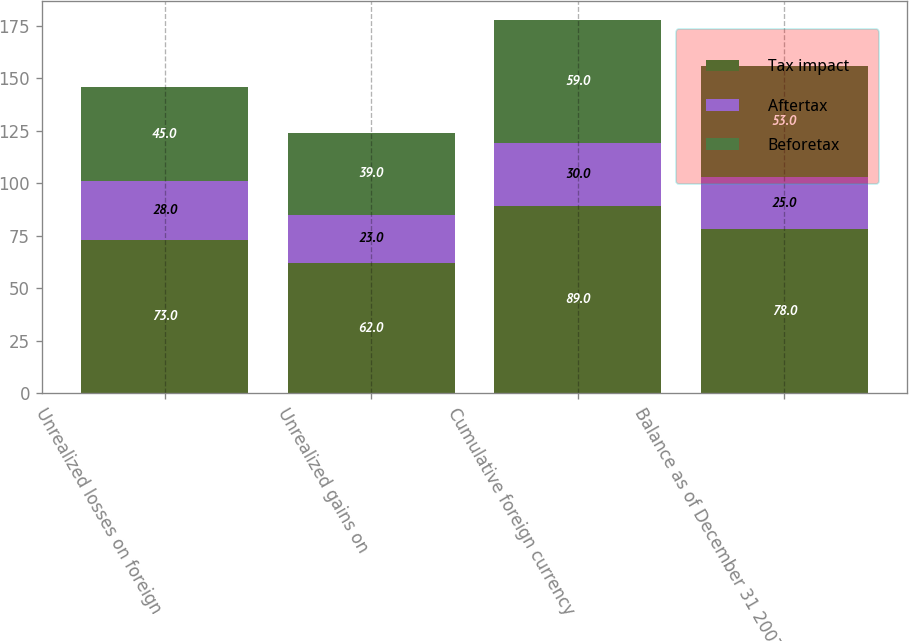Convert chart to OTSL. <chart><loc_0><loc_0><loc_500><loc_500><stacked_bar_chart><ecel><fcel>Unrealized losses on foreign<fcel>Unrealized gains on<fcel>Cumulative foreign currency<fcel>Balance as of December 31 2007<nl><fcel>Tax impact<fcel>73<fcel>62<fcel>89<fcel>78<nl><fcel>Aftertax<fcel>28<fcel>23<fcel>30<fcel>25<nl><fcel>Beforetax<fcel>45<fcel>39<fcel>59<fcel>53<nl></chart> 